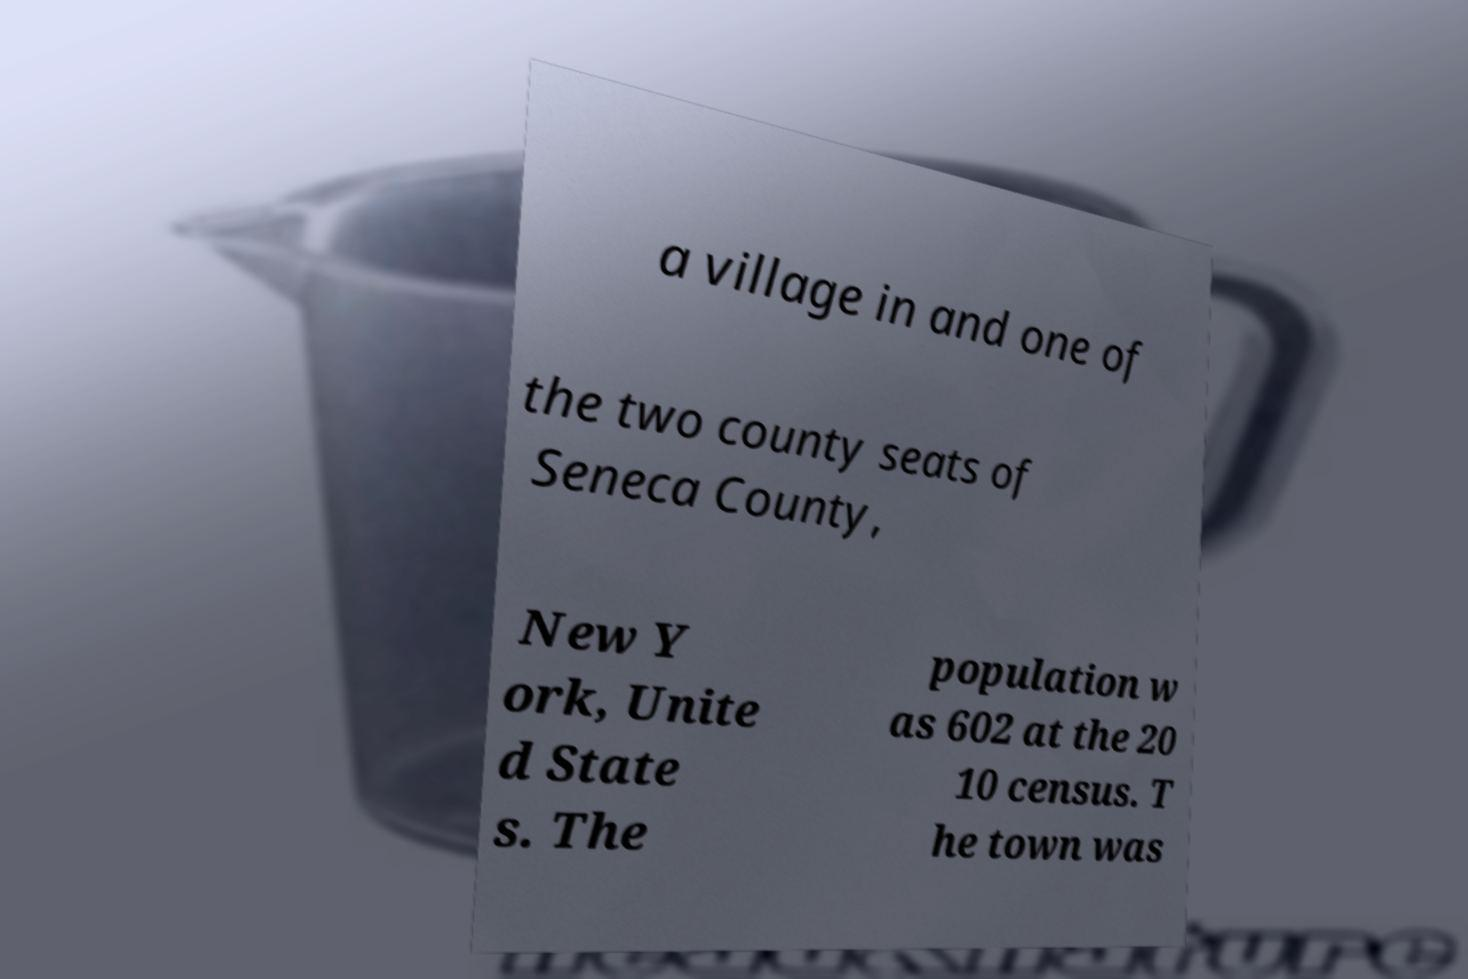For documentation purposes, I need the text within this image transcribed. Could you provide that? a village in and one of the two county seats of Seneca County, New Y ork, Unite d State s. The population w as 602 at the 20 10 census. T he town was 